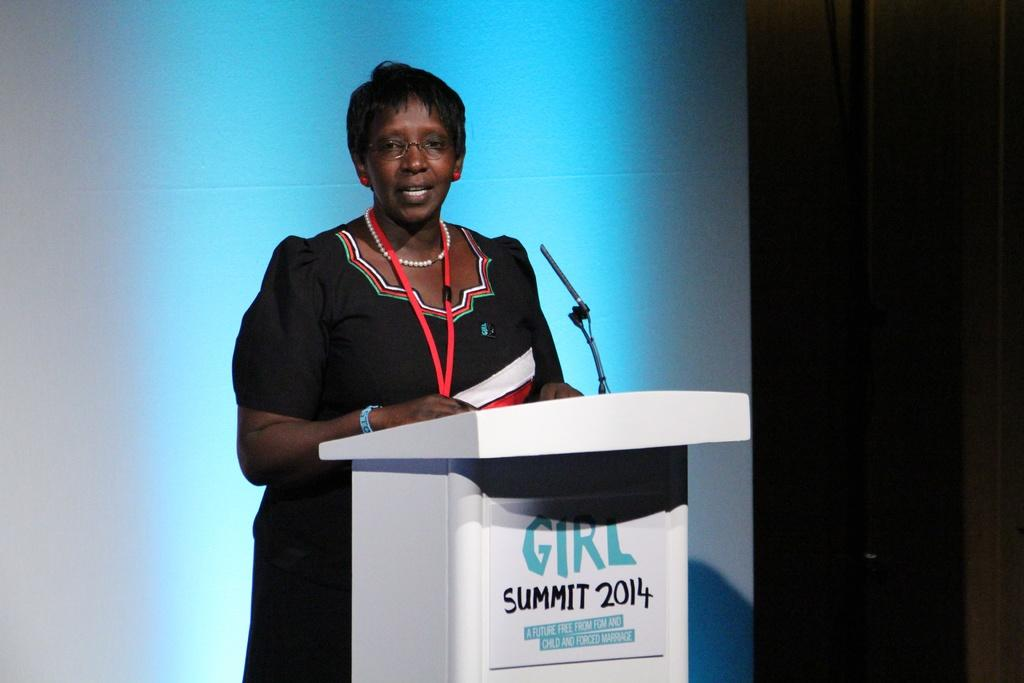<image>
Provide a brief description of the given image. A woman speaks at the 2014 Girl Summit. 